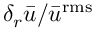Convert formula to latex. <formula><loc_0><loc_0><loc_500><loc_500>{ \delta _ { r } } \bar { u } / { { \bar { u } } ^ { r m s } }</formula> 